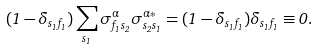Convert formula to latex. <formula><loc_0><loc_0><loc_500><loc_500>( 1 - \delta _ { s _ { 1 } f _ { 1 } } ) \sum _ { s _ { 1 } } \sigma ^ { \alpha } _ { f _ { 1 } s _ { 2 } } \sigma ^ { \alpha * } _ { s _ { 2 } s _ { 1 } } = ( 1 - \delta _ { s _ { 1 } f _ { 1 } } ) \delta _ { s _ { 1 } f _ { 1 } } \equiv 0 .</formula> 